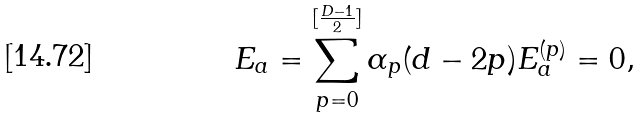<formula> <loc_0><loc_0><loc_500><loc_500>E _ { a } = \sum _ { p = 0 } ^ { [ \frac { D - 1 } { 2 } ] } \alpha _ { p } ( d - 2 p ) E _ { a } ^ { ( p ) } = 0 ,</formula> 